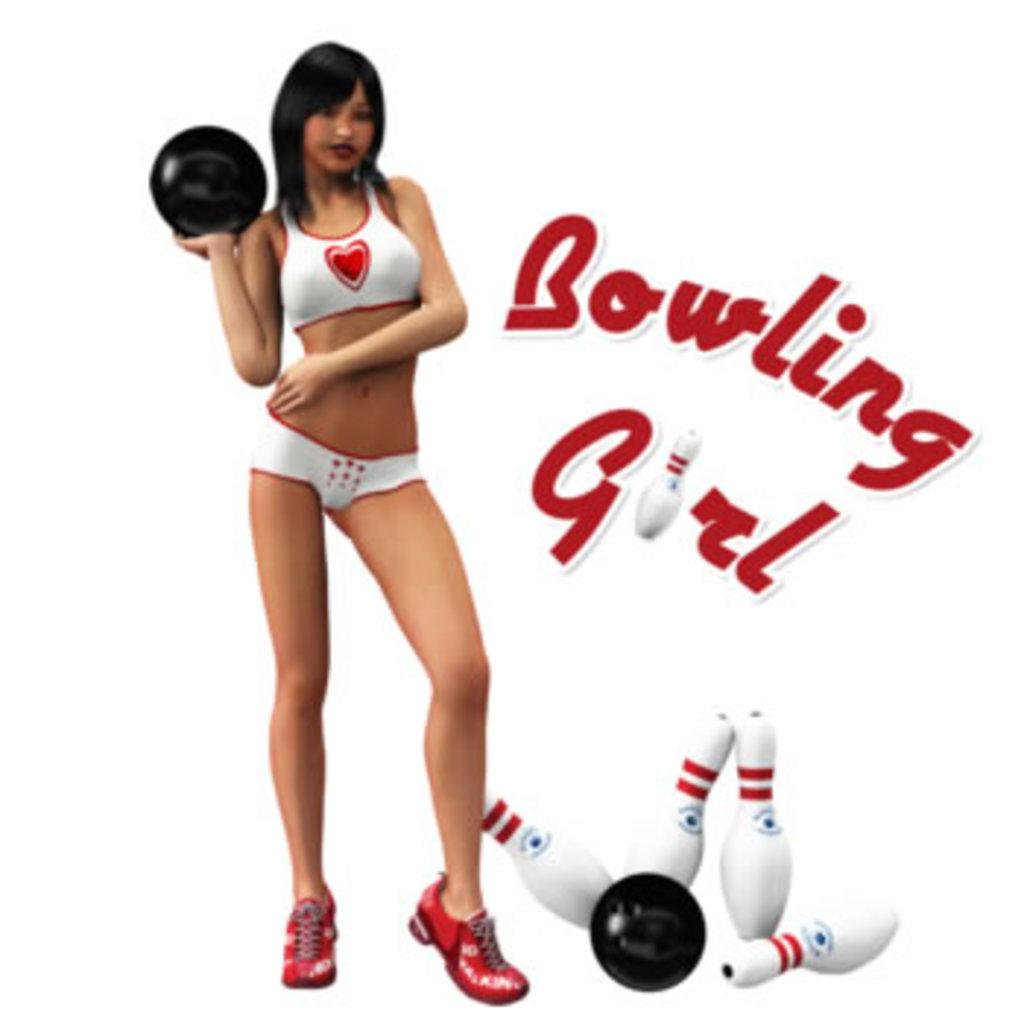Is this a bowling boy or girl?
Your answer should be compact. Girl. 